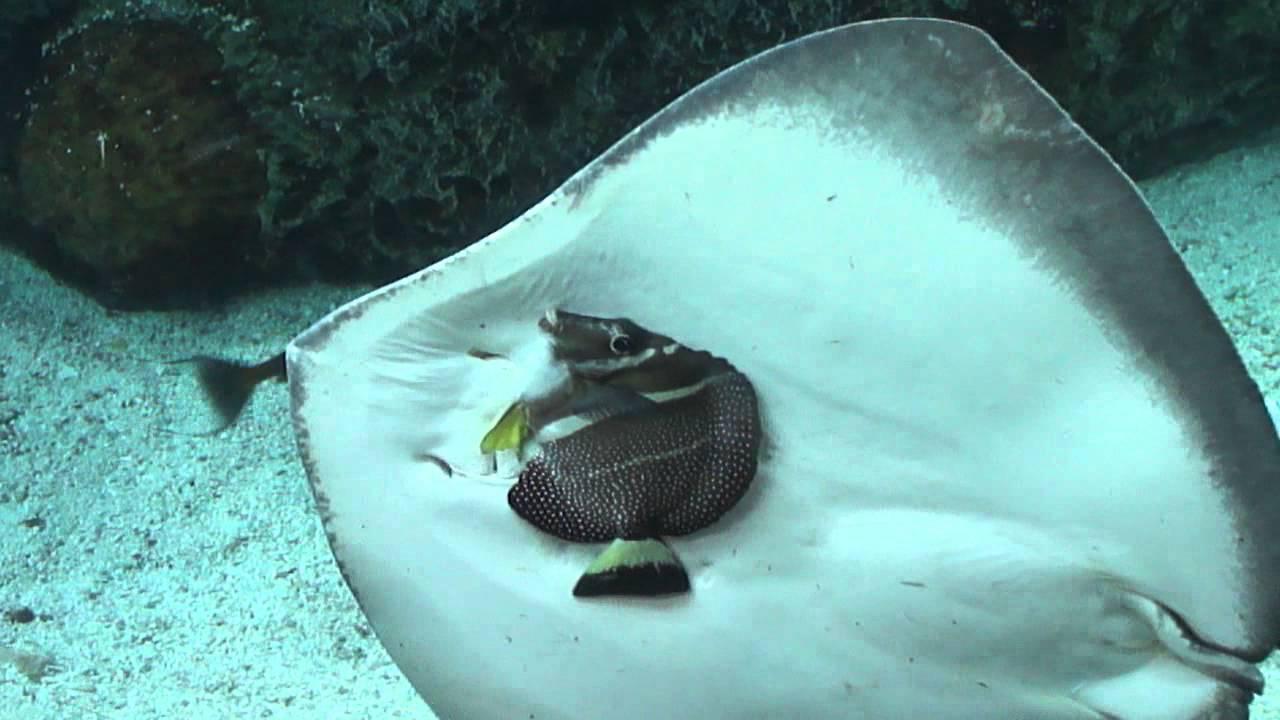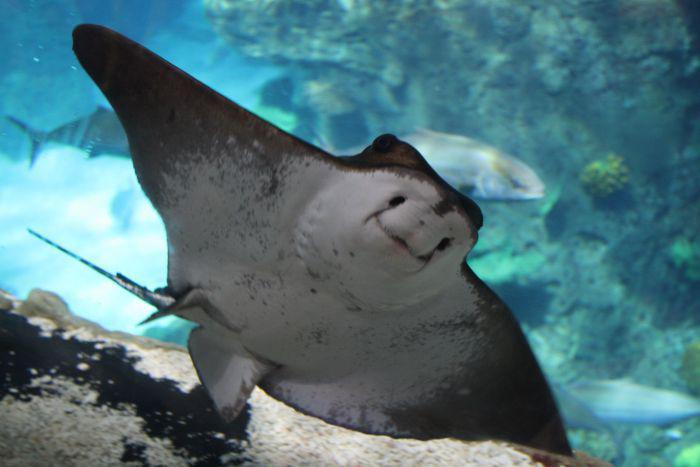The first image is the image on the left, the second image is the image on the right. For the images shown, is this caption "A person is in the water near the sting rays." true? Answer yes or no. No. The first image is the image on the left, the second image is the image on the right. Analyze the images presented: Is the assertion "A human hand is near the underside of a stingray in one image." valid? Answer yes or no. No. 